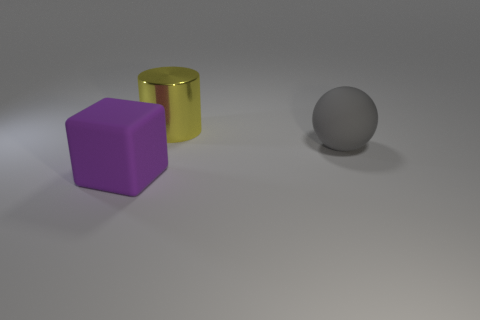Add 1 red rubber cubes. How many objects exist? 4 Subtract all cylinders. How many objects are left? 2 Subtract 0 red balls. How many objects are left? 3 Subtract all large rubber blocks. Subtract all large purple objects. How many objects are left? 1 Add 3 yellow metal objects. How many yellow metal objects are left? 4 Add 1 large purple matte cylinders. How many large purple matte cylinders exist? 1 